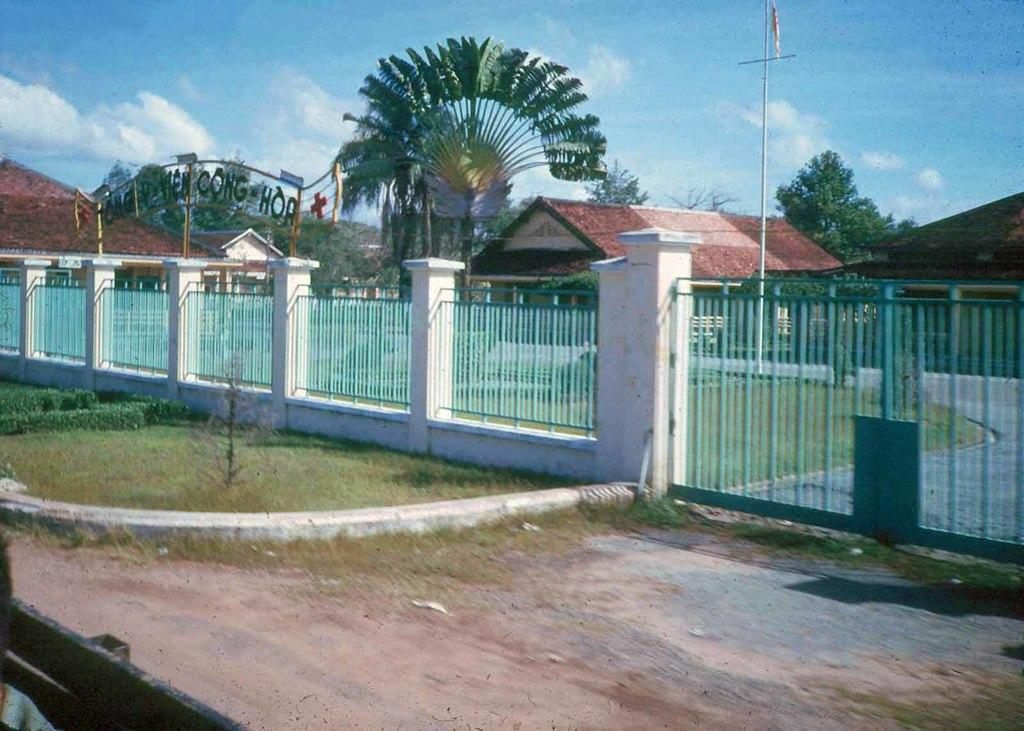What type of structures can be seen in the image? There are houses in the image. What else is present in the image besides the houses? There is a pole, trees, and fencing in the image. What can be seen in the background of the image? The sky is visible in the image. What type of texture can be seen on the moon in the image? There is no moon present in the image, so there is no texture to observe. 